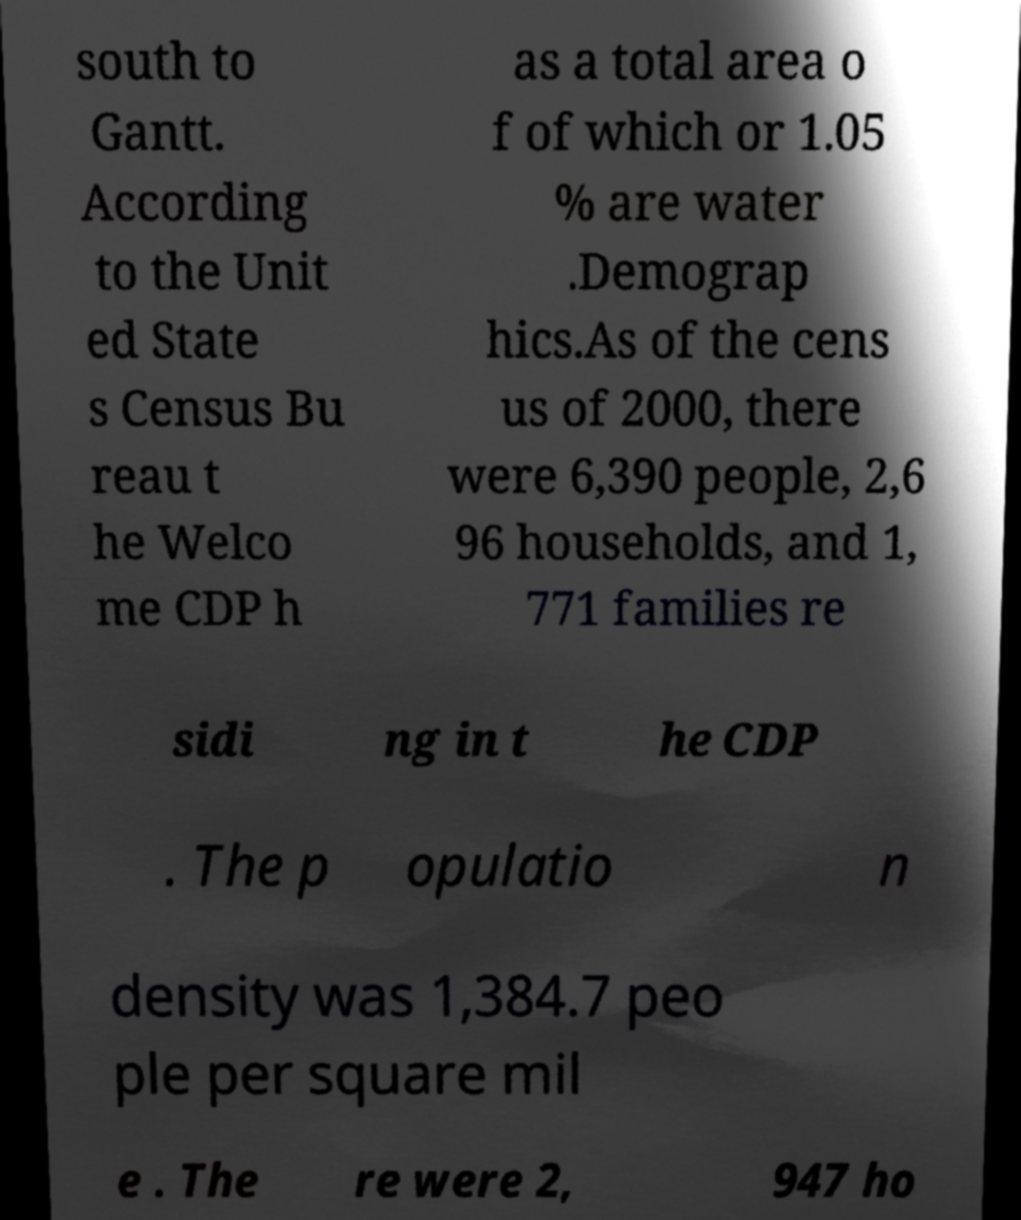There's text embedded in this image that I need extracted. Can you transcribe it verbatim? south to Gantt. According to the Unit ed State s Census Bu reau t he Welco me CDP h as a total area o f of which or 1.05 % are water .Demograp hics.As of the cens us of 2000, there were 6,390 people, 2,6 96 households, and 1, 771 families re sidi ng in t he CDP . The p opulatio n density was 1,384.7 peo ple per square mil e . The re were 2, 947 ho 